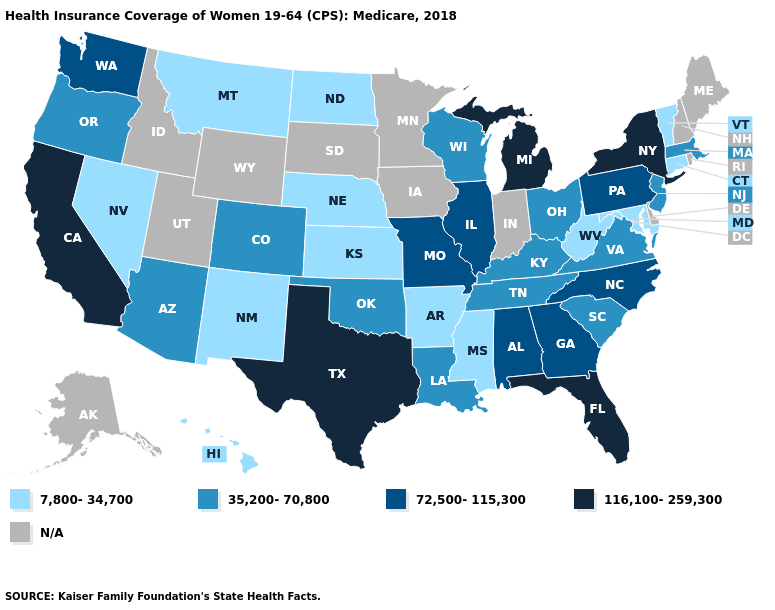Does the first symbol in the legend represent the smallest category?
Quick response, please. Yes. What is the value of Texas?
Quick response, please. 116,100-259,300. What is the highest value in the USA?
Write a very short answer. 116,100-259,300. Does Montana have the lowest value in the USA?
Concise answer only. Yes. Name the states that have a value in the range 116,100-259,300?
Quick response, please. California, Florida, Michigan, New York, Texas. What is the lowest value in the USA?
Concise answer only. 7,800-34,700. Does South Carolina have the lowest value in the USA?
Quick response, please. No. Which states hav the highest value in the MidWest?
Be succinct. Michigan. Name the states that have a value in the range 35,200-70,800?
Short answer required. Arizona, Colorado, Kentucky, Louisiana, Massachusetts, New Jersey, Ohio, Oklahoma, Oregon, South Carolina, Tennessee, Virginia, Wisconsin. Among the states that border Massachusetts , which have the highest value?
Concise answer only. New York. Does Vermont have the lowest value in the Northeast?
Answer briefly. Yes. Does Texas have the highest value in the USA?
Quick response, please. Yes. What is the value of California?
Concise answer only. 116,100-259,300. What is the lowest value in the USA?
Concise answer only. 7,800-34,700. 